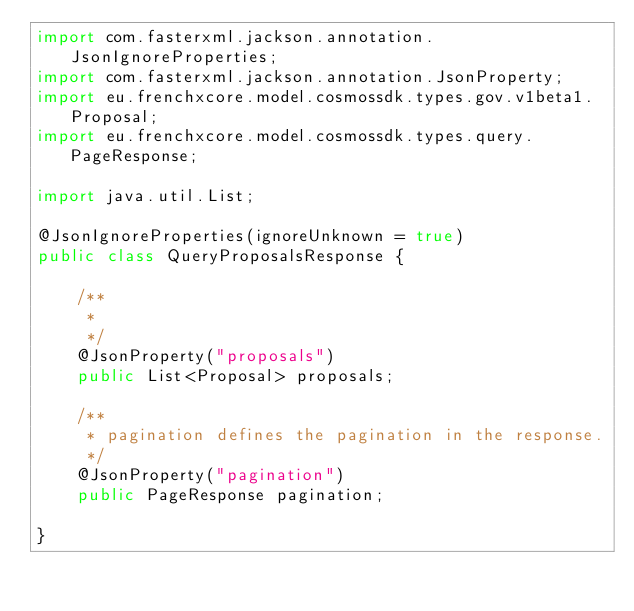Convert code to text. <code><loc_0><loc_0><loc_500><loc_500><_Java_>import com.fasterxml.jackson.annotation.JsonIgnoreProperties;
import com.fasterxml.jackson.annotation.JsonProperty;
import eu.frenchxcore.model.cosmossdk.types.gov.v1beta1.Proposal;
import eu.frenchxcore.model.cosmossdk.types.query.PageResponse;

import java.util.List;

@JsonIgnoreProperties(ignoreUnknown = true)
public class QueryProposalsResponse {

    /**
     * 
     */
    @JsonProperty("proposals")
    public List<Proposal> proposals;

    /**
     * pagination defines the pagination in the response.
     */
    @JsonProperty("pagination")
    public PageResponse pagination;
    
}
</code> 